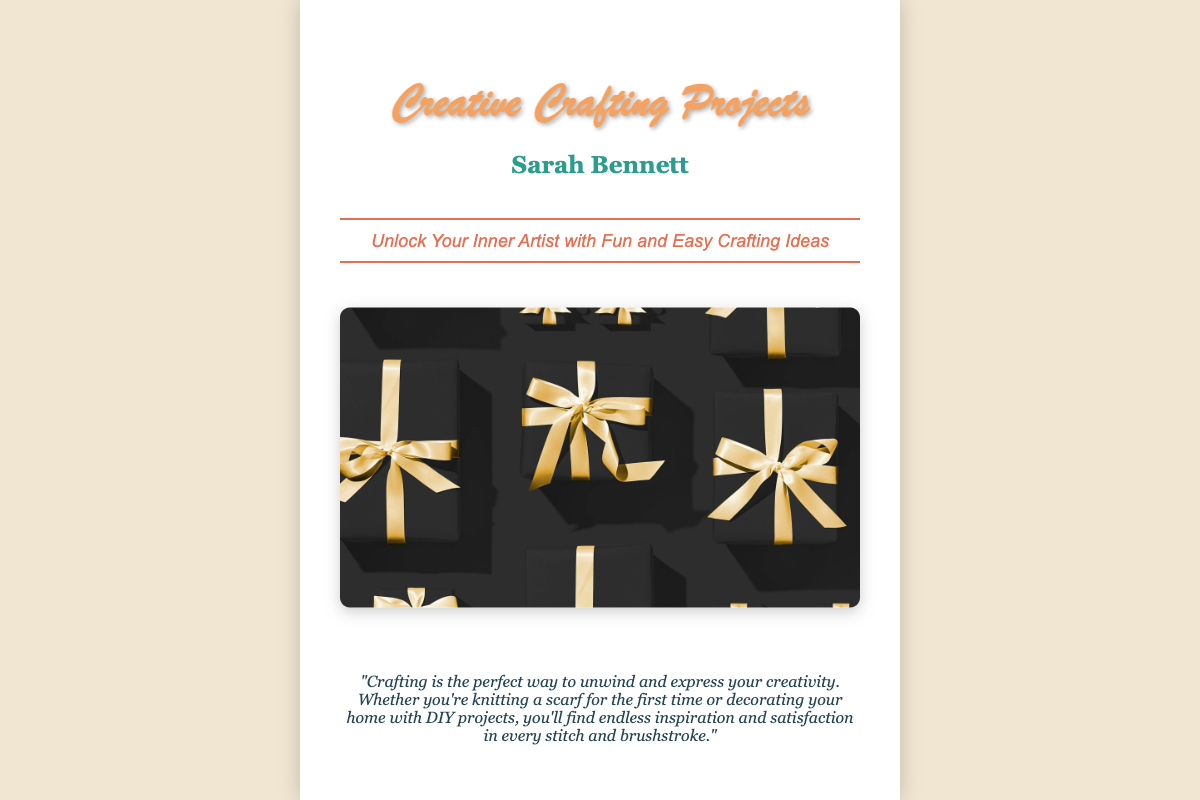What is the title of the book? The title of the book is prominently displayed in a large font on the cover.
Answer: Creative Crafting Projects Who is the author of the book? The author's name is also displayed near the title, indicating who wrote the book.
Answer: Sarah Bennett What is the tagline of the book? The tagline is a brief description or promotional sentence under the title that captures the essence of the book.
Answer: Unlock Your Inner Artist with Fun and Easy Crafting Ideas What is the quote about crafting saying? The quote relates to the overall theme of the book and reflects the author's perspective on crafting.
Answer: "Crafting is the perfect way to unwind and express your creativity." How many main images are included in the cover? The cover features a distinct section for a main image that represents the crafting theme.
Answer: One What color is the title text? The title text color contributes to the visual appeal and readability of the cover design.
Answer: #f4a261 What style is the author’s name printed in? The font choice for the author's name adds to the aesthetic and may convey professionalism or creativity.
Answer: Georgia, serif What is the primary background color of the book cover? The background color is an essential aspect of the overall design, giving a foundation to the visual elements.
Answer: White What type of projects does the book focus on? The title indicates the specific kind of activities that the book will guide the reader through.
Answer: Crafting Projects 